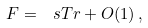Convert formula to latex. <formula><loc_0><loc_0><loc_500><loc_500>\ F = \ s T r + O ( 1 ) \, ,</formula> 